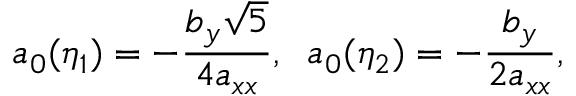Convert formula to latex. <formula><loc_0><loc_0><loc_500><loc_500>a _ { 0 } ( \eta _ { 1 } ) = - \frac { b _ { y } \sqrt { 5 } } { 4 a _ { x x } } , \, a _ { 0 } ( \eta _ { 2 } ) = - \frac { b _ { y } } { 2 a _ { x x } } ,</formula> 